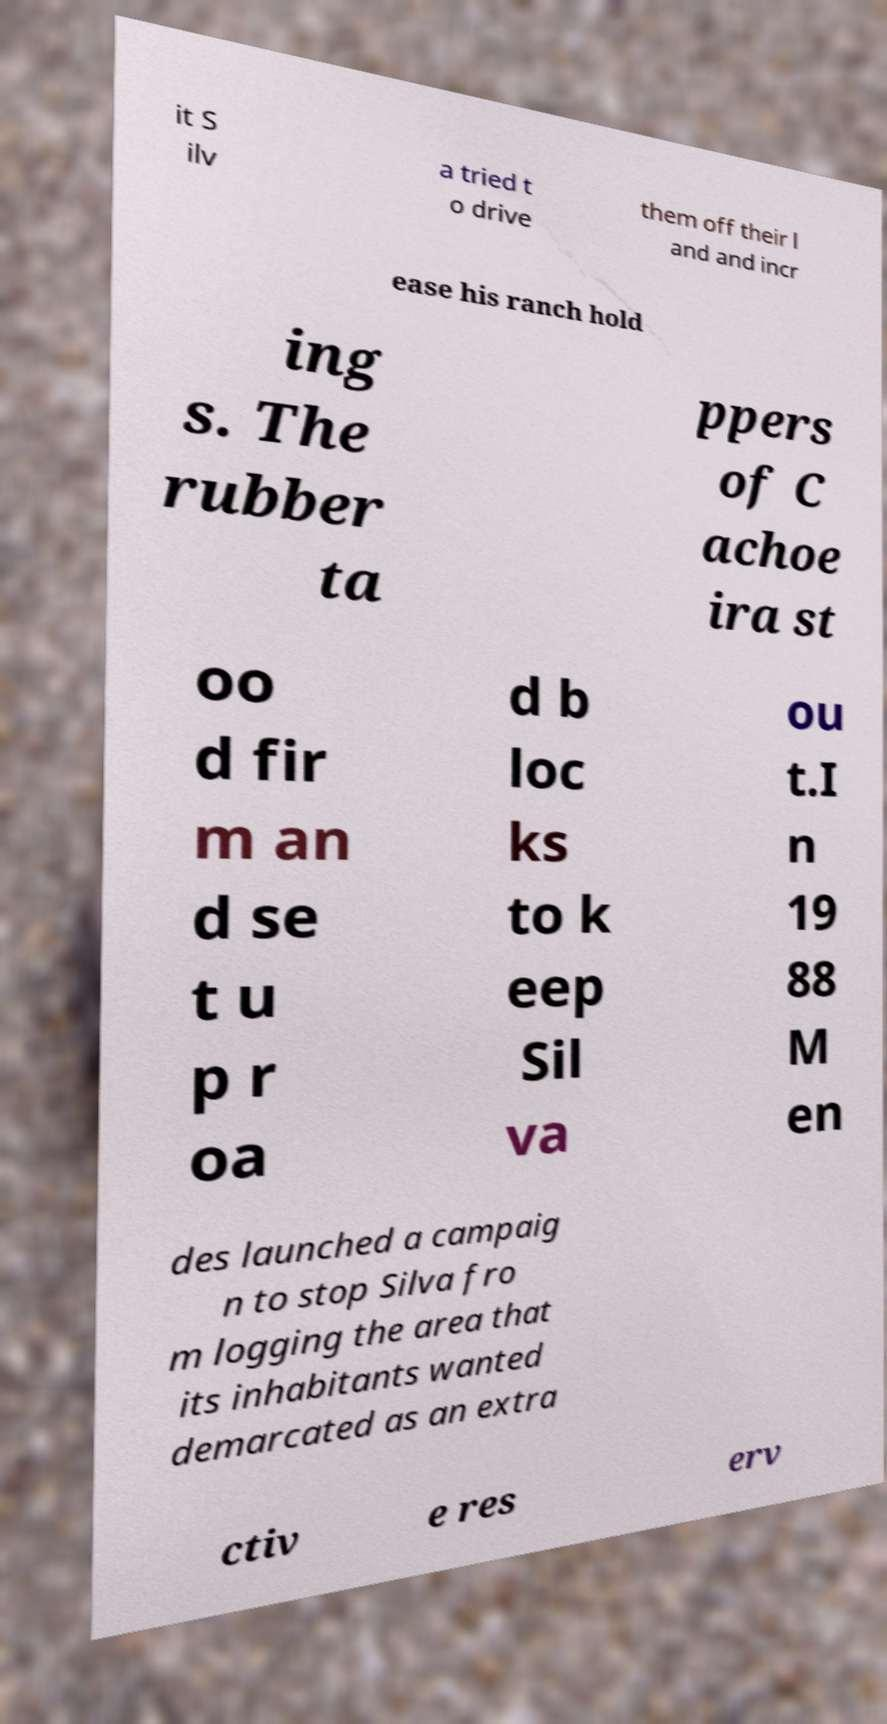I need the written content from this picture converted into text. Can you do that? it S ilv a tried t o drive them off their l and and incr ease his ranch hold ing s. The rubber ta ppers of C achoe ira st oo d fir m an d se t u p r oa d b loc ks to k eep Sil va ou t.I n 19 88 M en des launched a campaig n to stop Silva fro m logging the area that its inhabitants wanted demarcated as an extra ctiv e res erv 